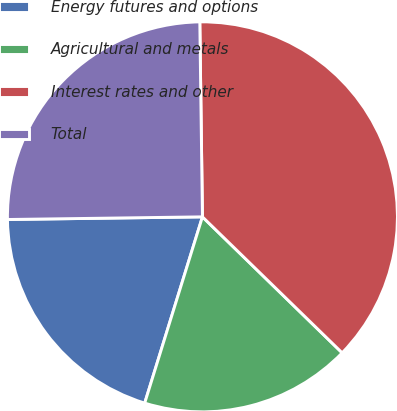Convert chart to OTSL. <chart><loc_0><loc_0><loc_500><loc_500><pie_chart><fcel>Energy futures and options<fcel>Agricultural and metals<fcel>Interest rates and other<fcel>Total<nl><fcel>20.0%<fcel>17.5%<fcel>37.5%<fcel>25.0%<nl></chart> 